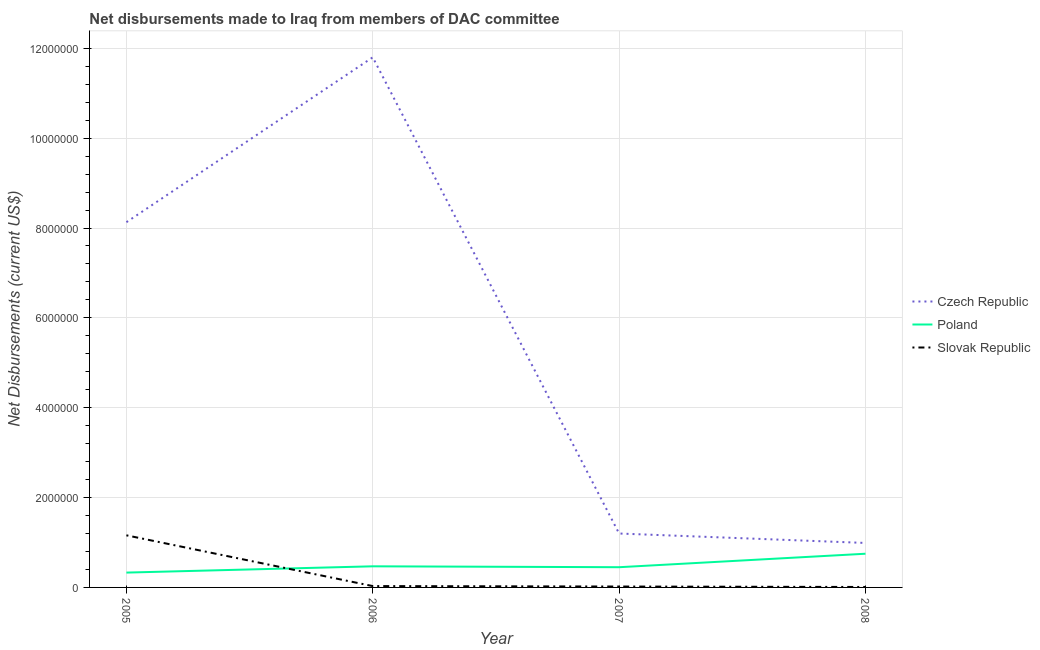Is the number of lines equal to the number of legend labels?
Provide a short and direct response. Yes. What is the net disbursements made by poland in 2007?
Your response must be concise. 4.50e+05. Across all years, what is the maximum net disbursements made by poland?
Your answer should be very brief. 7.50e+05. Across all years, what is the minimum net disbursements made by poland?
Your response must be concise. 3.30e+05. In which year was the net disbursements made by poland minimum?
Provide a succinct answer. 2005. What is the total net disbursements made by slovak republic in the graph?
Provide a succinct answer. 1.22e+06. What is the difference between the net disbursements made by czech republic in 2007 and that in 2008?
Offer a very short reply. 2.10e+05. What is the difference between the net disbursements made by slovak republic in 2008 and the net disbursements made by czech republic in 2005?
Offer a very short reply. -8.12e+06. What is the average net disbursements made by czech republic per year?
Provide a short and direct response. 5.53e+06. In the year 2005, what is the difference between the net disbursements made by czech republic and net disbursements made by poland?
Your answer should be compact. 7.80e+06. What is the ratio of the net disbursements made by poland in 2005 to that in 2006?
Your answer should be compact. 0.7. Is the difference between the net disbursements made by poland in 2005 and 2007 greater than the difference between the net disbursements made by czech republic in 2005 and 2007?
Provide a short and direct response. No. What is the difference between the highest and the second highest net disbursements made by poland?
Provide a succinct answer. 2.80e+05. What is the difference between the highest and the lowest net disbursements made by slovak republic?
Keep it short and to the point. 1.15e+06. Is the sum of the net disbursements made by slovak republic in 2007 and 2008 greater than the maximum net disbursements made by poland across all years?
Provide a short and direct response. No. Does the net disbursements made by czech republic monotonically increase over the years?
Provide a succinct answer. No. Is the net disbursements made by slovak republic strictly less than the net disbursements made by czech republic over the years?
Make the answer very short. Yes. What is the difference between two consecutive major ticks on the Y-axis?
Ensure brevity in your answer.  2.00e+06. Are the values on the major ticks of Y-axis written in scientific E-notation?
Offer a terse response. No. What is the title of the graph?
Keep it short and to the point. Net disbursements made to Iraq from members of DAC committee. Does "Ages 0-14" appear as one of the legend labels in the graph?
Make the answer very short. No. What is the label or title of the X-axis?
Your answer should be compact. Year. What is the label or title of the Y-axis?
Ensure brevity in your answer.  Net Disbursements (current US$). What is the Net Disbursements (current US$) of Czech Republic in 2005?
Keep it short and to the point. 8.13e+06. What is the Net Disbursements (current US$) of Slovak Republic in 2005?
Provide a short and direct response. 1.16e+06. What is the Net Disbursements (current US$) in Czech Republic in 2006?
Make the answer very short. 1.18e+07. What is the Net Disbursements (current US$) in Poland in 2006?
Ensure brevity in your answer.  4.70e+05. What is the Net Disbursements (current US$) in Czech Republic in 2007?
Ensure brevity in your answer.  1.20e+06. What is the Net Disbursements (current US$) of Slovak Republic in 2007?
Provide a short and direct response. 2.00e+04. What is the Net Disbursements (current US$) in Czech Republic in 2008?
Provide a short and direct response. 9.90e+05. What is the Net Disbursements (current US$) of Poland in 2008?
Your response must be concise. 7.50e+05. Across all years, what is the maximum Net Disbursements (current US$) in Czech Republic?
Give a very brief answer. 1.18e+07. Across all years, what is the maximum Net Disbursements (current US$) of Poland?
Provide a short and direct response. 7.50e+05. Across all years, what is the maximum Net Disbursements (current US$) in Slovak Republic?
Your answer should be very brief. 1.16e+06. Across all years, what is the minimum Net Disbursements (current US$) in Czech Republic?
Keep it short and to the point. 9.90e+05. Across all years, what is the minimum Net Disbursements (current US$) in Poland?
Provide a succinct answer. 3.30e+05. Across all years, what is the minimum Net Disbursements (current US$) in Slovak Republic?
Keep it short and to the point. 10000. What is the total Net Disbursements (current US$) of Czech Republic in the graph?
Provide a short and direct response. 2.21e+07. What is the total Net Disbursements (current US$) of Poland in the graph?
Make the answer very short. 2.00e+06. What is the total Net Disbursements (current US$) of Slovak Republic in the graph?
Your answer should be very brief. 1.22e+06. What is the difference between the Net Disbursements (current US$) in Czech Republic in 2005 and that in 2006?
Give a very brief answer. -3.67e+06. What is the difference between the Net Disbursements (current US$) in Slovak Republic in 2005 and that in 2006?
Your answer should be compact. 1.13e+06. What is the difference between the Net Disbursements (current US$) of Czech Republic in 2005 and that in 2007?
Keep it short and to the point. 6.93e+06. What is the difference between the Net Disbursements (current US$) of Slovak Republic in 2005 and that in 2007?
Offer a very short reply. 1.14e+06. What is the difference between the Net Disbursements (current US$) of Czech Republic in 2005 and that in 2008?
Offer a very short reply. 7.14e+06. What is the difference between the Net Disbursements (current US$) of Poland in 2005 and that in 2008?
Offer a very short reply. -4.20e+05. What is the difference between the Net Disbursements (current US$) in Slovak Republic in 2005 and that in 2008?
Offer a very short reply. 1.15e+06. What is the difference between the Net Disbursements (current US$) in Czech Republic in 2006 and that in 2007?
Keep it short and to the point. 1.06e+07. What is the difference between the Net Disbursements (current US$) in Czech Republic in 2006 and that in 2008?
Keep it short and to the point. 1.08e+07. What is the difference between the Net Disbursements (current US$) of Poland in 2006 and that in 2008?
Your response must be concise. -2.80e+05. What is the difference between the Net Disbursements (current US$) in Slovak Republic in 2006 and that in 2008?
Make the answer very short. 2.00e+04. What is the difference between the Net Disbursements (current US$) of Czech Republic in 2007 and that in 2008?
Your answer should be very brief. 2.10e+05. What is the difference between the Net Disbursements (current US$) of Poland in 2007 and that in 2008?
Your response must be concise. -3.00e+05. What is the difference between the Net Disbursements (current US$) in Slovak Republic in 2007 and that in 2008?
Your response must be concise. 10000. What is the difference between the Net Disbursements (current US$) of Czech Republic in 2005 and the Net Disbursements (current US$) of Poland in 2006?
Make the answer very short. 7.66e+06. What is the difference between the Net Disbursements (current US$) of Czech Republic in 2005 and the Net Disbursements (current US$) of Slovak Republic in 2006?
Your response must be concise. 8.10e+06. What is the difference between the Net Disbursements (current US$) of Poland in 2005 and the Net Disbursements (current US$) of Slovak Republic in 2006?
Your response must be concise. 3.00e+05. What is the difference between the Net Disbursements (current US$) in Czech Republic in 2005 and the Net Disbursements (current US$) in Poland in 2007?
Make the answer very short. 7.68e+06. What is the difference between the Net Disbursements (current US$) of Czech Republic in 2005 and the Net Disbursements (current US$) of Slovak Republic in 2007?
Give a very brief answer. 8.11e+06. What is the difference between the Net Disbursements (current US$) in Czech Republic in 2005 and the Net Disbursements (current US$) in Poland in 2008?
Offer a terse response. 7.38e+06. What is the difference between the Net Disbursements (current US$) of Czech Republic in 2005 and the Net Disbursements (current US$) of Slovak Republic in 2008?
Your answer should be compact. 8.12e+06. What is the difference between the Net Disbursements (current US$) of Poland in 2005 and the Net Disbursements (current US$) of Slovak Republic in 2008?
Provide a short and direct response. 3.20e+05. What is the difference between the Net Disbursements (current US$) in Czech Republic in 2006 and the Net Disbursements (current US$) in Poland in 2007?
Give a very brief answer. 1.14e+07. What is the difference between the Net Disbursements (current US$) in Czech Republic in 2006 and the Net Disbursements (current US$) in Slovak Republic in 2007?
Provide a succinct answer. 1.18e+07. What is the difference between the Net Disbursements (current US$) of Poland in 2006 and the Net Disbursements (current US$) of Slovak Republic in 2007?
Offer a very short reply. 4.50e+05. What is the difference between the Net Disbursements (current US$) of Czech Republic in 2006 and the Net Disbursements (current US$) of Poland in 2008?
Keep it short and to the point. 1.10e+07. What is the difference between the Net Disbursements (current US$) in Czech Republic in 2006 and the Net Disbursements (current US$) in Slovak Republic in 2008?
Offer a very short reply. 1.18e+07. What is the difference between the Net Disbursements (current US$) in Poland in 2006 and the Net Disbursements (current US$) in Slovak Republic in 2008?
Make the answer very short. 4.60e+05. What is the difference between the Net Disbursements (current US$) in Czech Republic in 2007 and the Net Disbursements (current US$) in Slovak Republic in 2008?
Keep it short and to the point. 1.19e+06. What is the difference between the Net Disbursements (current US$) of Poland in 2007 and the Net Disbursements (current US$) of Slovak Republic in 2008?
Your answer should be very brief. 4.40e+05. What is the average Net Disbursements (current US$) in Czech Republic per year?
Give a very brief answer. 5.53e+06. What is the average Net Disbursements (current US$) in Slovak Republic per year?
Your answer should be very brief. 3.05e+05. In the year 2005, what is the difference between the Net Disbursements (current US$) in Czech Republic and Net Disbursements (current US$) in Poland?
Your answer should be very brief. 7.80e+06. In the year 2005, what is the difference between the Net Disbursements (current US$) of Czech Republic and Net Disbursements (current US$) of Slovak Republic?
Ensure brevity in your answer.  6.97e+06. In the year 2005, what is the difference between the Net Disbursements (current US$) of Poland and Net Disbursements (current US$) of Slovak Republic?
Ensure brevity in your answer.  -8.30e+05. In the year 2006, what is the difference between the Net Disbursements (current US$) of Czech Republic and Net Disbursements (current US$) of Poland?
Keep it short and to the point. 1.13e+07. In the year 2006, what is the difference between the Net Disbursements (current US$) in Czech Republic and Net Disbursements (current US$) in Slovak Republic?
Make the answer very short. 1.18e+07. In the year 2006, what is the difference between the Net Disbursements (current US$) in Poland and Net Disbursements (current US$) in Slovak Republic?
Your answer should be very brief. 4.40e+05. In the year 2007, what is the difference between the Net Disbursements (current US$) of Czech Republic and Net Disbursements (current US$) of Poland?
Your response must be concise. 7.50e+05. In the year 2007, what is the difference between the Net Disbursements (current US$) in Czech Republic and Net Disbursements (current US$) in Slovak Republic?
Ensure brevity in your answer.  1.18e+06. In the year 2008, what is the difference between the Net Disbursements (current US$) in Czech Republic and Net Disbursements (current US$) in Slovak Republic?
Your response must be concise. 9.80e+05. In the year 2008, what is the difference between the Net Disbursements (current US$) in Poland and Net Disbursements (current US$) in Slovak Republic?
Your answer should be compact. 7.40e+05. What is the ratio of the Net Disbursements (current US$) of Czech Republic in 2005 to that in 2006?
Provide a short and direct response. 0.69. What is the ratio of the Net Disbursements (current US$) in Poland in 2005 to that in 2006?
Ensure brevity in your answer.  0.7. What is the ratio of the Net Disbursements (current US$) in Slovak Republic in 2005 to that in 2006?
Your answer should be very brief. 38.67. What is the ratio of the Net Disbursements (current US$) of Czech Republic in 2005 to that in 2007?
Your response must be concise. 6.78. What is the ratio of the Net Disbursements (current US$) of Poland in 2005 to that in 2007?
Your answer should be compact. 0.73. What is the ratio of the Net Disbursements (current US$) of Slovak Republic in 2005 to that in 2007?
Offer a terse response. 58. What is the ratio of the Net Disbursements (current US$) in Czech Republic in 2005 to that in 2008?
Offer a terse response. 8.21. What is the ratio of the Net Disbursements (current US$) of Poland in 2005 to that in 2008?
Keep it short and to the point. 0.44. What is the ratio of the Net Disbursements (current US$) of Slovak Republic in 2005 to that in 2008?
Your answer should be compact. 116. What is the ratio of the Net Disbursements (current US$) in Czech Republic in 2006 to that in 2007?
Keep it short and to the point. 9.83. What is the ratio of the Net Disbursements (current US$) of Poland in 2006 to that in 2007?
Your response must be concise. 1.04. What is the ratio of the Net Disbursements (current US$) of Slovak Republic in 2006 to that in 2007?
Make the answer very short. 1.5. What is the ratio of the Net Disbursements (current US$) in Czech Republic in 2006 to that in 2008?
Provide a succinct answer. 11.92. What is the ratio of the Net Disbursements (current US$) in Poland in 2006 to that in 2008?
Make the answer very short. 0.63. What is the ratio of the Net Disbursements (current US$) of Slovak Republic in 2006 to that in 2008?
Provide a succinct answer. 3. What is the ratio of the Net Disbursements (current US$) of Czech Republic in 2007 to that in 2008?
Offer a terse response. 1.21. What is the ratio of the Net Disbursements (current US$) of Poland in 2007 to that in 2008?
Offer a terse response. 0.6. What is the difference between the highest and the second highest Net Disbursements (current US$) of Czech Republic?
Offer a terse response. 3.67e+06. What is the difference between the highest and the second highest Net Disbursements (current US$) in Poland?
Your response must be concise. 2.80e+05. What is the difference between the highest and the second highest Net Disbursements (current US$) in Slovak Republic?
Offer a very short reply. 1.13e+06. What is the difference between the highest and the lowest Net Disbursements (current US$) of Czech Republic?
Offer a very short reply. 1.08e+07. What is the difference between the highest and the lowest Net Disbursements (current US$) of Slovak Republic?
Offer a terse response. 1.15e+06. 